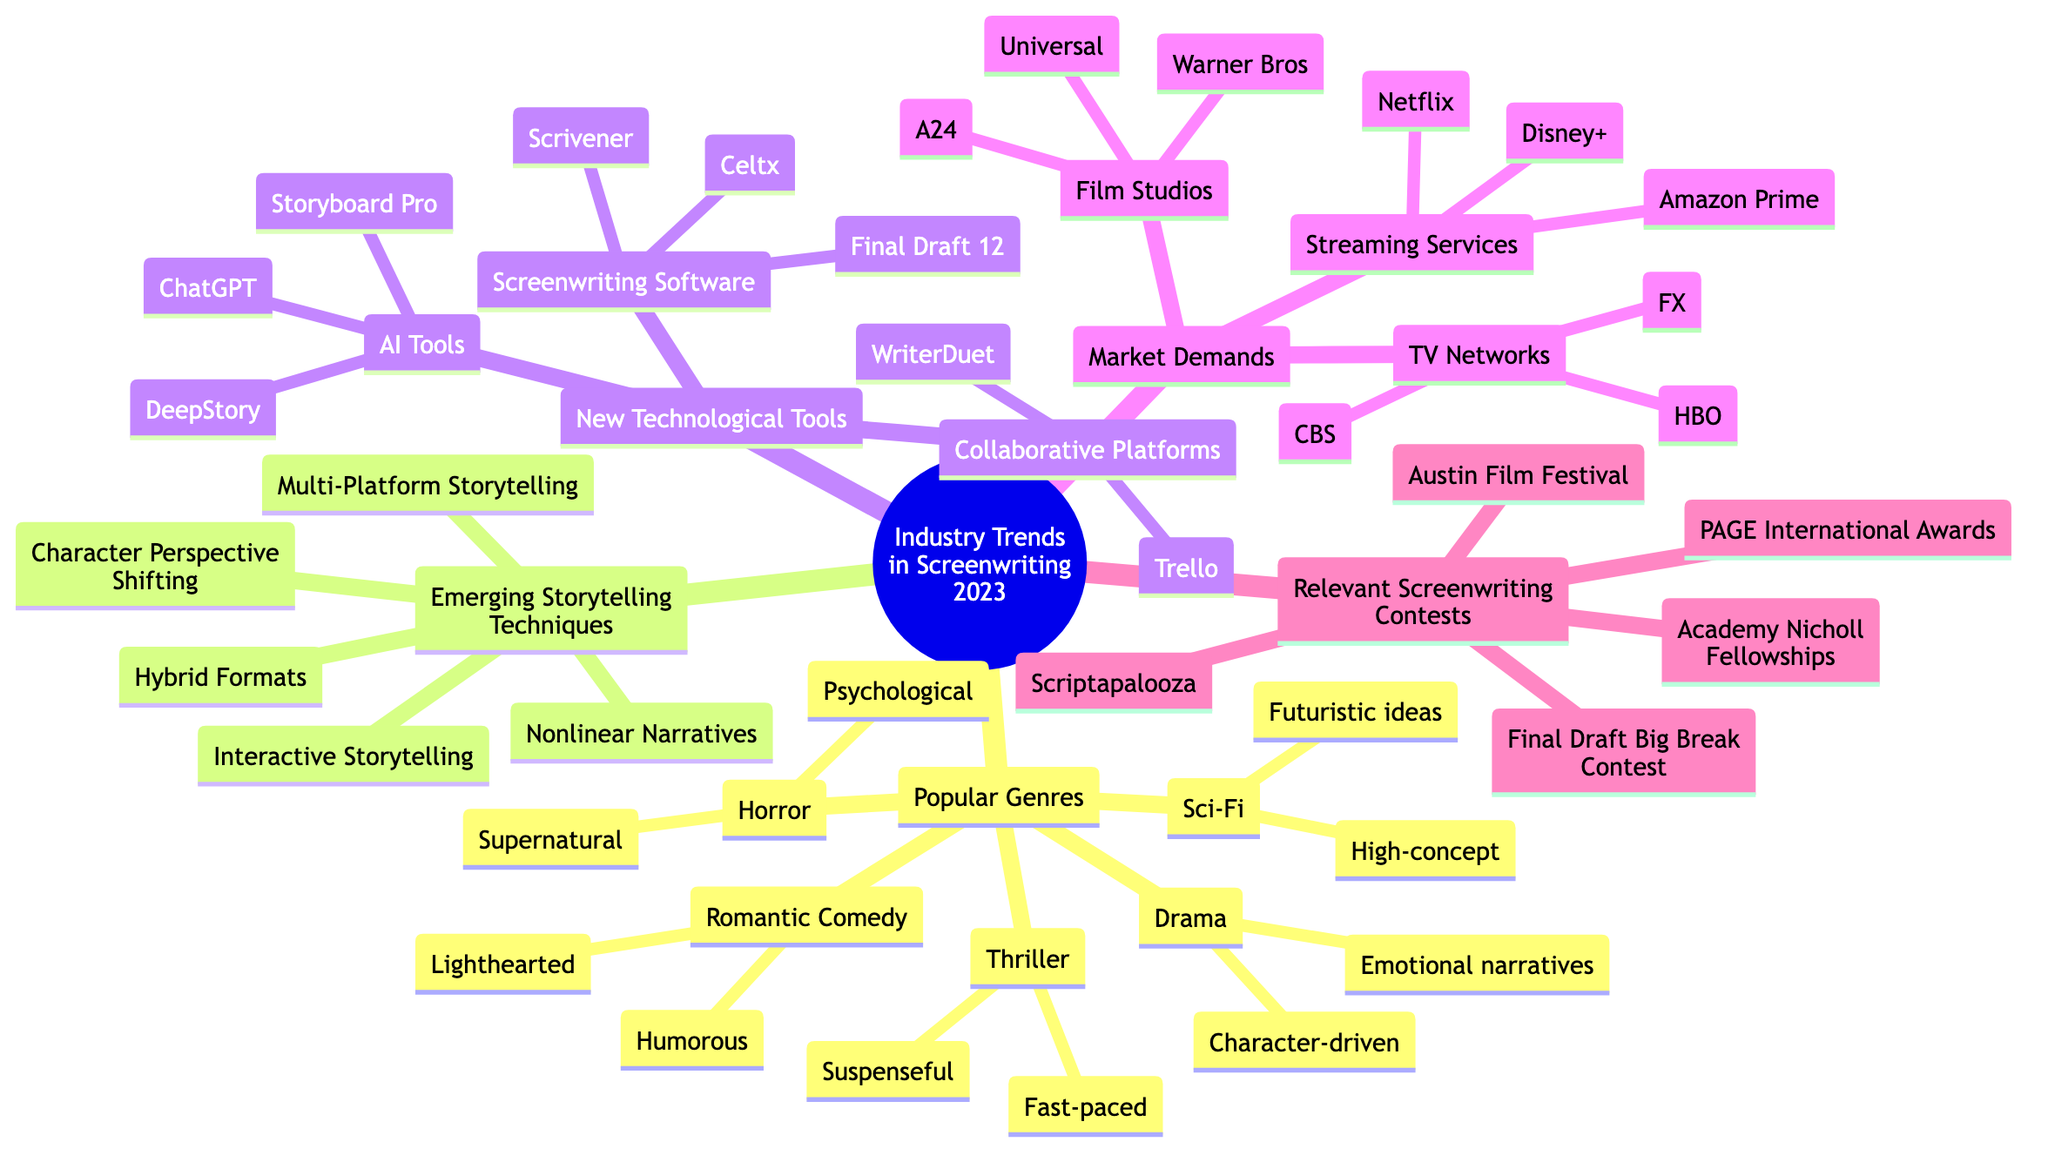What are the popular genres listed in the diagram? The diagram specifies five popular genres: Drama, Sci-Fi, Thriller, Romantic Comedy, and Horror. This can be identified by looking at the "Popular Genres" node and its connected sub-nodes.
Answer: Drama, Sci-Fi, Thriller, Romantic Comedy, Horror How many emerging storytelling techniques are mentioned? The diagram lists five emerging storytelling techniques: Nonlinear Narratives, Interactive Storytelling, Multi-Platform Storytelling, Character Perspective Shifting, and Hybrid Formats. Count the sub-nodes connected to "Emerging Storytelling Techniques" to find this number.
Answer: 5 Which screenwriting software is categorized under "New Technological Tools"? Under "Screenwriting Software," the diagram lists Final Draft 12, Celtx, and Scrivener. By examining the sub-nodes under the "New Technological Tools" node, we can see these specific software tools are mentioned.
Answer: Final Draft 12, Celtx, Scrivener What is the primary demand of Netflix according to the diagram? The diagram indicates that Netflix has a high demand for diverse, original content. This information is found under the "Streaming Services" section, specifically connected to the Netflix node.
Answer: High demand for diverse, original content Which screenwriting contest is recognized as prestigious? The diagram categorizes the Academy Nicholl Fellowships as a prestigious screenwriting competition in the "Relevant Screenwriting Contests" section. This can be verified by locating its node in the diagram.
Answer: Academy Nicholl Fellowships What type of storytelling technique involves audience participation? Interactive Storytelling, noted in the emerging storytelling techniques, involves audience participation influencing the plot. This specific technique is highlighted under the "Emerging Storytelling Techniques" section.
Answer: Interactive Storytelling How many film studios are mentioned in the market demands? The diagram names three film studios: Warner Bros, A24, and Universal. Count the sub-nodes under the "Film Studios" section to determine this number.
Answer: 3 Which AI tool is specified for brainstorming dialogue? ChatGPT is identified as the AI tool for brainstorming dialogue and plot points. This information is derived from the "AI Tools" subsection under "New Technological Tools."
Answer: ChatGPT 